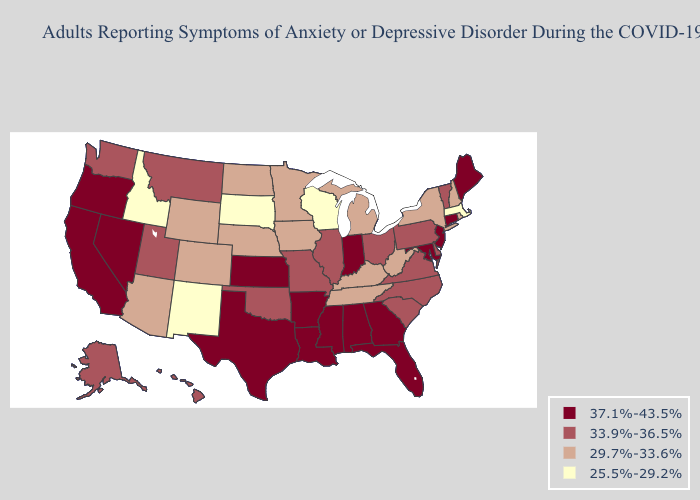Does North Dakota have the highest value in the USA?
Give a very brief answer. No. Name the states that have a value in the range 33.9%-36.5%?
Give a very brief answer. Alaska, Delaware, Hawaii, Illinois, Missouri, Montana, North Carolina, Ohio, Oklahoma, Pennsylvania, South Carolina, Utah, Vermont, Virginia, Washington. Name the states that have a value in the range 33.9%-36.5%?
Answer briefly. Alaska, Delaware, Hawaii, Illinois, Missouri, Montana, North Carolina, Ohio, Oklahoma, Pennsylvania, South Carolina, Utah, Vermont, Virginia, Washington. Name the states that have a value in the range 29.7%-33.6%?
Short answer required. Arizona, Colorado, Iowa, Kentucky, Michigan, Minnesota, Nebraska, New Hampshire, New York, North Dakota, Rhode Island, Tennessee, West Virginia, Wyoming. Does Maryland have the highest value in the South?
Write a very short answer. Yes. How many symbols are there in the legend?
Quick response, please. 4. What is the value of North Dakota?
Keep it brief. 29.7%-33.6%. What is the lowest value in the West?
Be succinct. 25.5%-29.2%. What is the value of New Mexico?
Concise answer only. 25.5%-29.2%. What is the lowest value in the South?
Keep it brief. 29.7%-33.6%. What is the highest value in the MidWest ?
Write a very short answer. 37.1%-43.5%. What is the value of Texas?
Answer briefly. 37.1%-43.5%. Among the states that border Indiana , does Ohio have the lowest value?
Quick response, please. No. How many symbols are there in the legend?
Give a very brief answer. 4. Is the legend a continuous bar?
Quick response, please. No. 